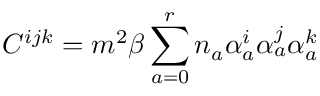<formula> <loc_0><loc_0><loc_500><loc_500>C ^ { i j k } = m ^ { 2 } \beta \sum _ { a = 0 } ^ { r } n _ { a } \alpha _ { a } ^ { i } \alpha _ { a } ^ { j } \alpha _ { a } ^ { k }</formula> 